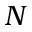<formula> <loc_0><loc_0><loc_500><loc_500>N</formula> 